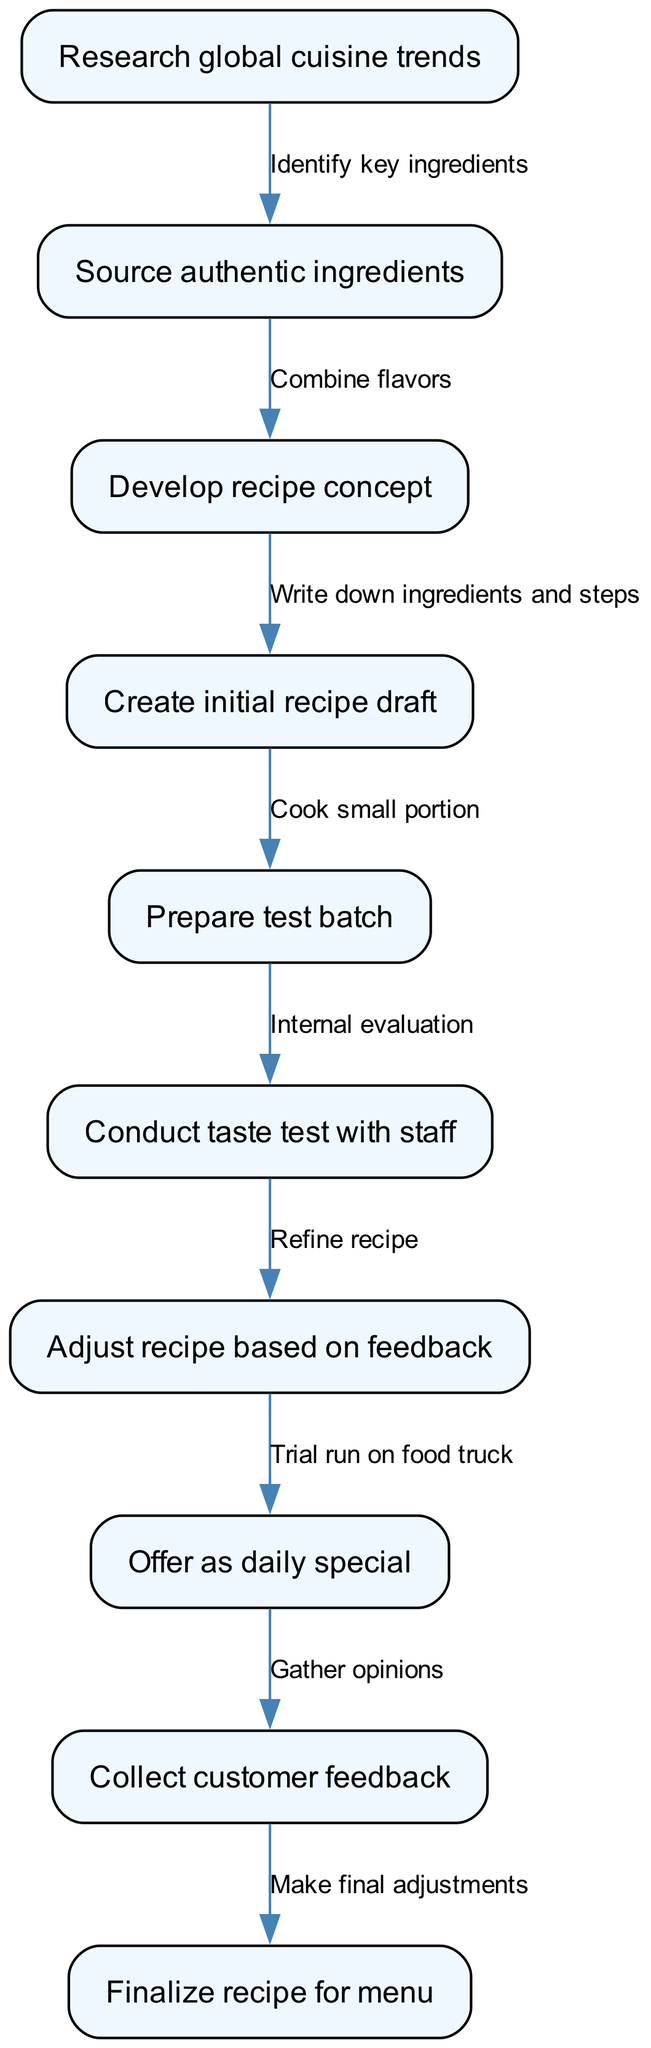What is the first step in the workflow? The first step in the workflow is "Research global cuisine trends." This is indicated by the first node in the diagram that initiates the pathway for recipe development.
Answer: Research global cuisine trends How many edges are in the diagram? There are ten edges in the diagram, connecting the various nodes. This can be counted from the list of edges provided in the data.
Answer: 10 What follows after "Create initial recipe draft"? The step that follows "Create initial recipe draft" is "Prepare test batch." This relationship is shown by the directed edge leading from node 4 to node 5.
Answer: Prepare test batch What happens after "Collect customer feedback"? After "Collect customer feedback," the step is "Finalize recipe for menu." This is the final step indicated by the directed edge from node 9 to node 10.
Answer: Finalize recipe for menu Which node is connected to "Adjust recipe based on feedback"? The node connected to "Adjust recipe based on feedback" is "Offer as daily special." This connection is shown through the directed edge from node 7 to node 8.
Answer: Offer as daily special How many nodes are there in the workflow? There are ten nodes in the workflow, which are the individual steps involved in the recipe development process. This can be verified by counting the nodes listed.
Answer: 10 Which step involves ingredient sourcing? The step that involves ingredient sourcing is "Source authentic ingredients." This is specified as the second node in the diagram that follows the initial research.
Answer: Source authentic ingredients What is the relationship between "Conduct taste test with staff" and "Prepare test batch"? The relationship is that "Conduct taste test with staff" occurs after "Prepare test batch." This is indicated by the directed edge from node 5 to node 6 in the workflow.
Answer: Conduct taste test with staff 